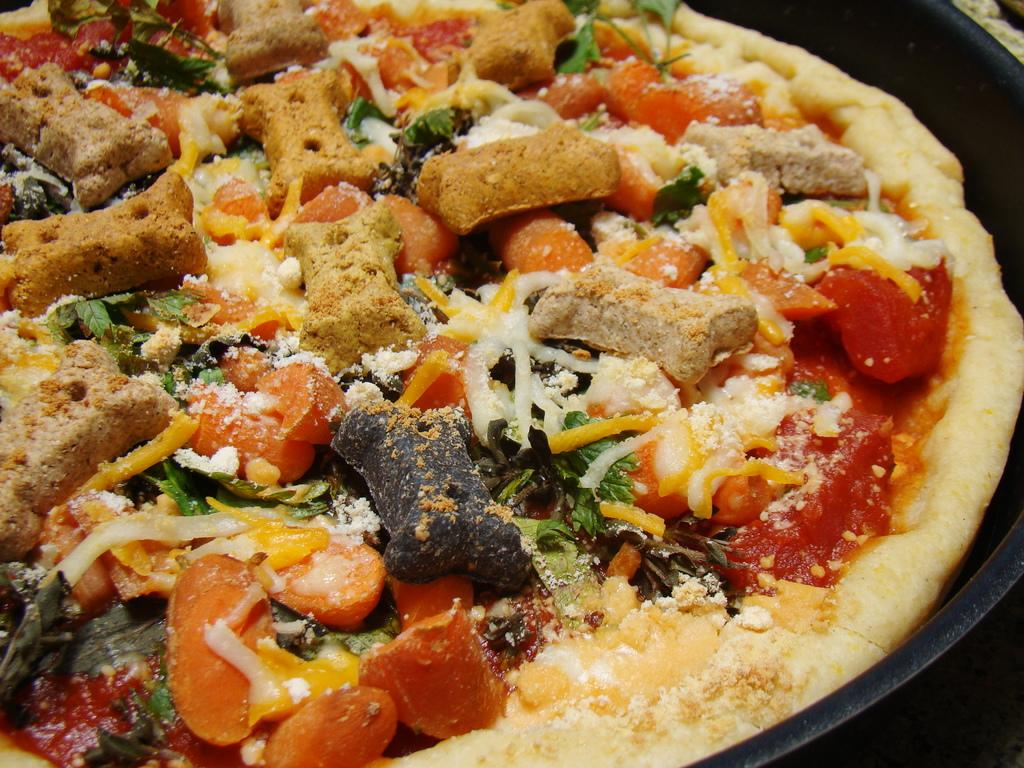What type of food is shown in the image? There is a pizza in the image. How is the pizza being held or contained? The pizza is in a pan. What type of treatment is being administered to the ear in the image? There is no ear or treatment present in the image; it only features a pizza in a pan. 